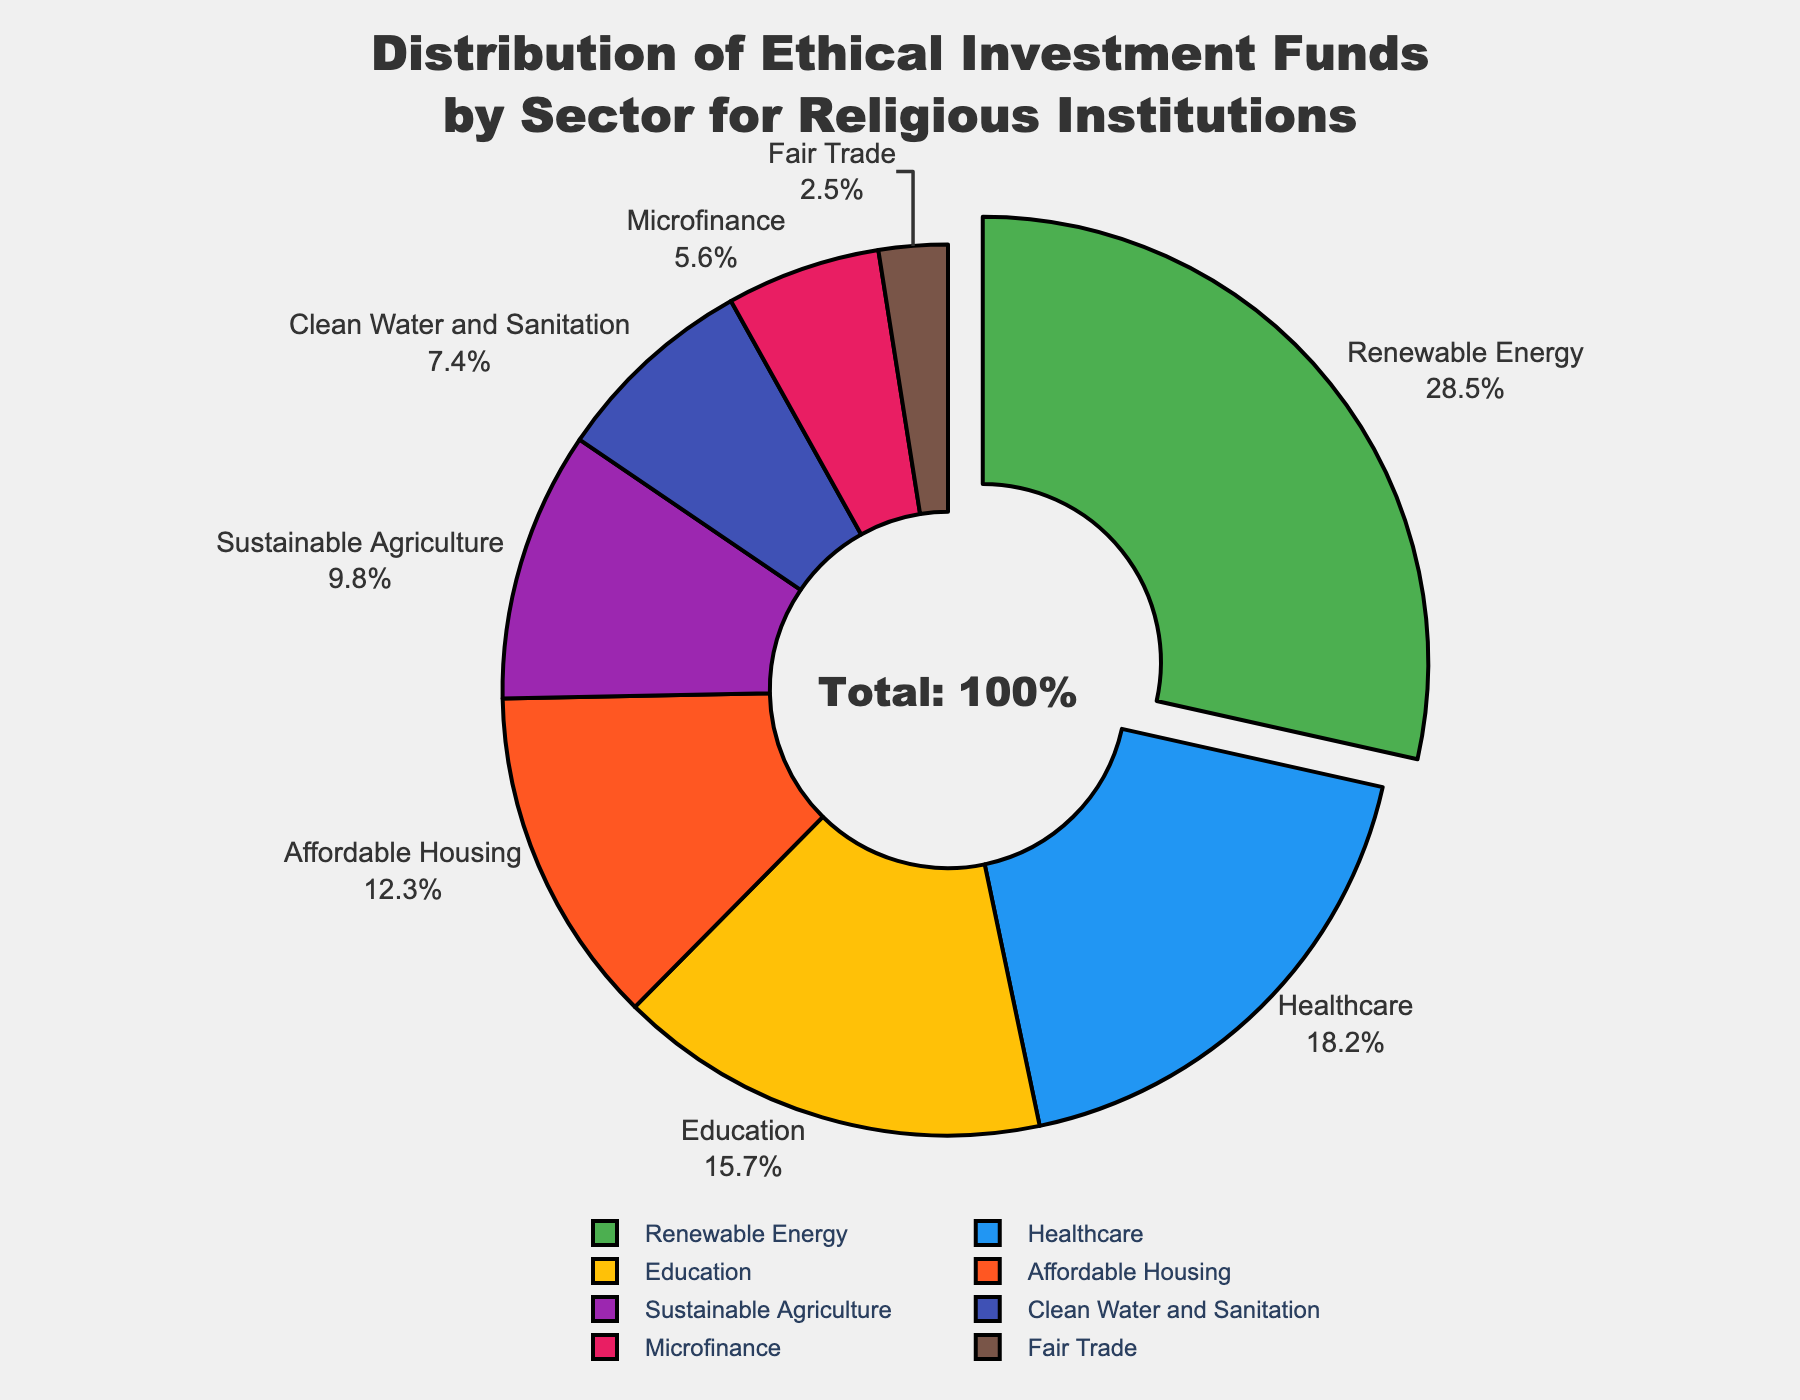What sector has the highest percentage of ethical investment funds? The sector with the highest percentage of ethical investment funds can be identified by looking at which section of the pie chart is the largest or is pulled out from the center. In this case, the largest section is for Renewable Energy.
Answer: Renewable Energy How much more investment is allocated to Renewable Energy compared to Fair Trade? To find how much more investment is allocated to Renewable Energy compared to Fair Trade, we subtract the percentage of Fair Trade from the percentage of Renewable Energy (28.5% - 2.5%).
Answer: 26% Is the investment in Clean Water and Sanitation greater than in Microfinance? To determine if the investment in Clean Water and Sanitation is greater than in Microfinance, we compare their percentages. Clean Water and Sanitation has 7.4%, whereas Microfinance has 5.6%. Since 7.4% is greater than 5.6%, the investment is greater.
Answer: Yes What is the combined percentage of investment in Healthcare and Education? To find the combined percentage of investment in Healthcare and Education, we add the percentages of these two sectors (18.2% for Healthcare + 15.7% for Education).
Answer: 33.9% What color represents the Affordable Housing sector? By looking at the pie chart, we can identify the color used to represent Affordable Housing. The sector has a distinct color used in the visual representation.
Answer: Orange (assuming #FF5722 corresponds to it as per provided color code context) How does investment in Sustainable Agriculture compare to investment in Microfinance? Comparing the percentages of Sustainable Agriculture (9.8%) and Microfinance (5.6%) from the pie chart, we see that Sustainable Agriculture has a higher percentage than Microfinance.
Answer: Sustainable Agriculture has more Which sector has the smallest share of the investment funds? The sector with the smallest share can be identified by looking at the pie chart section with the smallest size. This is the Fair Trade sector.
Answer: Fair Trade What is the average percentage allocated across all sectors? To find the average percentage allocated across all sectors, sum all percentages and divide by the number of sectors: (28.5 + 18.2 + 15.7 + 12.3 + 9.8 + 7.4 + 5.6 + 2.5) / 8.
Answer: 12.5% How does the percentage of investment in Education compare to the total percentage of investment in the sectors other than Renewable Energy? To compare, first subtract Renewable Energy's percentage from the total (100% - 28.5% = 71.5%). Then compare Education's 15.7% to this value. Education's share is substantially less.
Answer: Education has less Which three sectors together make up more than 50% of the total ethical investment funds? To find which three sectors together make up more than 50%, identify the largest percentages and sum them until the total surpasses 50%. The top three sectors are Renewable Energy (28.5%), Healthcare (18.2%), and Education (15.7%). 28.5 + 18.2 + 15.7 = 62.4%, which is more than 50%.
Answer: Renewable Energy, Healthcare, and Education 